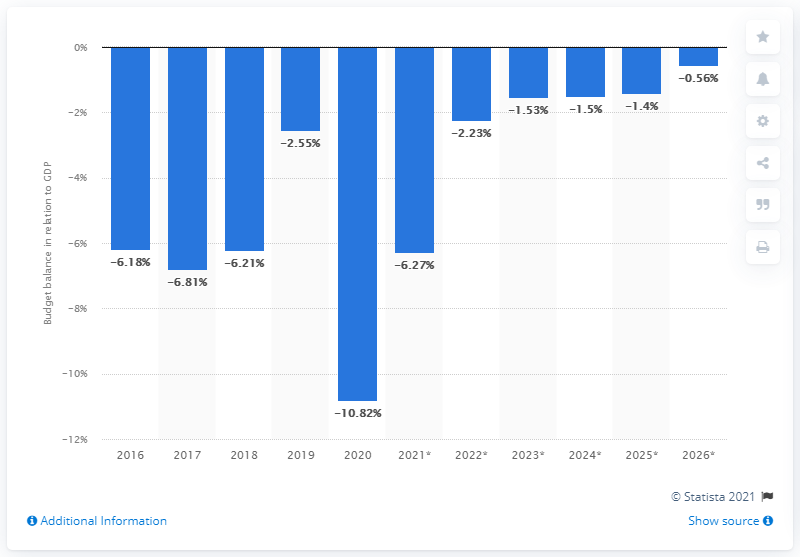Identify some key points in this picture. The budget balance of Montenegro is expected to end in 2020. 